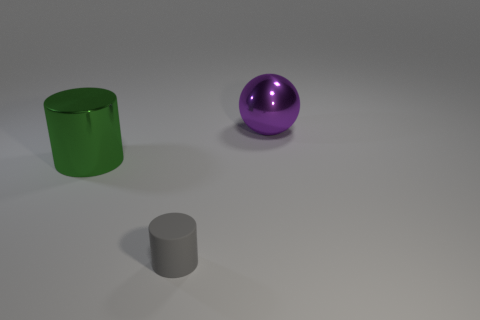Add 2 metallic things. How many objects exist? 5 Subtract all gray cylinders. How many cylinders are left? 1 Subtract all spheres. How many objects are left? 2 Subtract 1 cylinders. How many cylinders are left? 1 Subtract all gray cylinders. Subtract all purple metallic objects. How many objects are left? 1 Add 3 tiny rubber cylinders. How many tiny rubber cylinders are left? 4 Add 2 large green metallic objects. How many large green metallic objects exist? 3 Subtract 0 cyan blocks. How many objects are left? 3 Subtract all brown cylinders. Subtract all brown cubes. How many cylinders are left? 2 